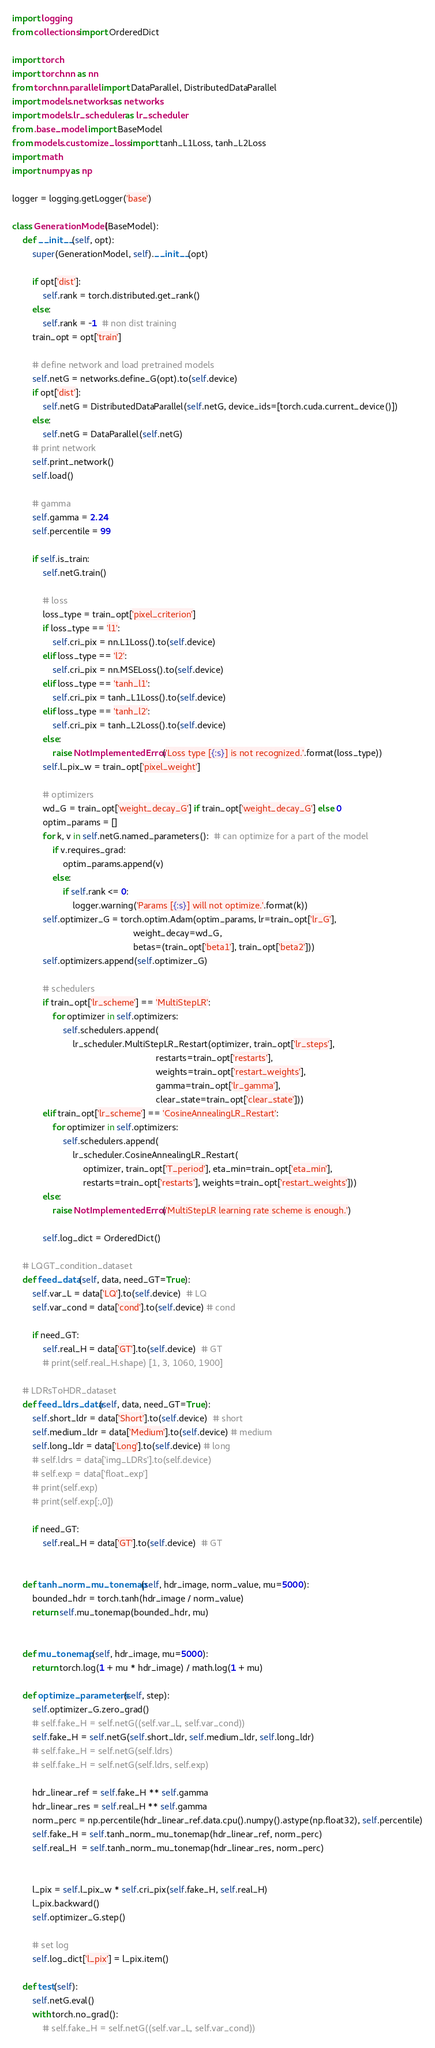<code> <loc_0><loc_0><loc_500><loc_500><_Python_>import logging
from collections import OrderedDict

import torch
import torch.nn as nn
from torch.nn.parallel import DataParallel, DistributedDataParallel
import models.networks as networks
import models.lr_scheduler as lr_scheduler
from .base_model import BaseModel
from models.customize_loss import tanh_L1Loss, tanh_L2Loss
import math
import numpy as np

logger = logging.getLogger('base')

class GenerationModel(BaseModel):
    def __init__(self, opt):
        super(GenerationModel, self).__init__(opt)

        if opt['dist']:
            self.rank = torch.distributed.get_rank()
        else:
            self.rank = -1  # non dist training
        train_opt = opt['train']

        # define network and load pretrained models
        self.netG = networks.define_G(opt).to(self.device)
        if opt['dist']:
            self.netG = DistributedDataParallel(self.netG, device_ids=[torch.cuda.current_device()])
        else:
            self.netG = DataParallel(self.netG)
        # print network
        self.print_network()
        self.load()

        # gamma
        self.gamma = 2.24
        self.percentile = 99

        if self.is_train:
            self.netG.train()

            # loss
            loss_type = train_opt['pixel_criterion']
            if loss_type == 'l1':
                self.cri_pix = nn.L1Loss().to(self.device)
            elif loss_type == 'l2':
                self.cri_pix = nn.MSELoss().to(self.device)
            elif loss_type == 'tanh_l1':
                self.cri_pix = tanh_L1Loss().to(self.device)
            elif loss_type == 'tanh_l2':
                self.cri_pix = tanh_L2Loss().to(self.device)
            else:
                raise NotImplementedError('Loss type [{:s}] is not recognized.'.format(loss_type))
            self.l_pix_w = train_opt['pixel_weight']

            # optimizers
            wd_G = train_opt['weight_decay_G'] if train_opt['weight_decay_G'] else 0
            optim_params = []
            for k, v in self.netG.named_parameters():  # can optimize for a part of the model
                if v.requires_grad:
                    optim_params.append(v)
                else:
                    if self.rank <= 0:
                        logger.warning('Params [{:s}] will not optimize.'.format(k))
            self.optimizer_G = torch.optim.Adam(optim_params, lr=train_opt['lr_G'],
                                                weight_decay=wd_G,
                                                betas=(train_opt['beta1'], train_opt['beta2']))
            self.optimizers.append(self.optimizer_G)

            # schedulers
            if train_opt['lr_scheme'] == 'MultiStepLR':
                for optimizer in self.optimizers:
                    self.schedulers.append(
                        lr_scheduler.MultiStepLR_Restart(optimizer, train_opt['lr_steps'],
                                                         restarts=train_opt['restarts'],
                                                         weights=train_opt['restart_weights'],
                                                         gamma=train_opt['lr_gamma'],
                                                         clear_state=train_opt['clear_state']))
            elif train_opt['lr_scheme'] == 'CosineAnnealingLR_Restart':
                for optimizer in self.optimizers:
                    self.schedulers.append(
                        lr_scheduler.CosineAnnealingLR_Restart(
                            optimizer, train_opt['T_period'], eta_min=train_opt['eta_min'],
                            restarts=train_opt['restarts'], weights=train_opt['restart_weights']))
            else:
                raise NotImplementedError('MultiStepLR learning rate scheme is enough.')

            self.log_dict = OrderedDict()

    # LQGT_condition_dataset
    def feed_data(self, data, need_GT=True):
        self.var_L = data['LQ'].to(self.device)  # LQ
        self.var_cond = data['cond'].to(self.device) # cond
        
        if need_GT:
            self.real_H = data['GT'].to(self.device)  # GT
            # print(self.real_H.shape) [1, 3, 1060, 1900]
    
    # LDRsToHDR_dataset
    def feed_ldrs_data(self, data, need_GT=True):
        self.short_ldr = data['Short'].to(self.device)  # short
        self.medium_ldr = data['Medium'].to(self.device) # medium
        self.long_ldr = data['Long'].to(self.device) # long
        # self.ldrs = data['img_LDRs'].to(self.device)
        # self.exp = data['float_exp']
        # print(self.exp)
        # print(self.exp[:,0])

        if need_GT:
            self.real_H = data['GT'].to(self.device)  # GT


    def tanh_norm_mu_tonemap(self, hdr_image, norm_value, mu=5000):
        bounded_hdr = torch.tanh(hdr_image / norm_value)
        return self.mu_tonemap(bounded_hdr, mu)


    def mu_tonemap(self, hdr_image, mu=5000):
        return torch.log(1 + mu * hdr_image) / math.log(1 + mu)
    
    def optimize_parameters(self, step):
        self.optimizer_G.zero_grad()
        # self.fake_H = self.netG((self.var_L, self.var_cond))
        self.fake_H = self.netG(self.short_ldr, self.medium_ldr, self.long_ldr)
        # self.fake_H = self.netG(self.ldrs)
        # self.fake_H = self.netG(self.ldrs, self.exp)
        
        hdr_linear_ref = self.fake_H ** self.gamma
        hdr_linear_res = self.real_H ** self.gamma
        norm_perc = np.percentile(hdr_linear_ref.data.cpu().numpy().astype(np.float32), self.percentile)
        self.fake_H = self.tanh_norm_mu_tonemap(hdr_linear_ref, norm_perc)
        self.real_H  = self.tanh_norm_mu_tonemap(hdr_linear_res, norm_perc)


        l_pix = self.l_pix_w * self.cri_pix(self.fake_H, self.real_H)
        l_pix.backward()
        self.optimizer_G.step()

        # set log
        self.log_dict['l_pix'] = l_pix.item()

    def test(self):
        self.netG.eval()
        with torch.no_grad():
            # self.fake_H = self.netG((self.var_L, self.var_cond))</code> 